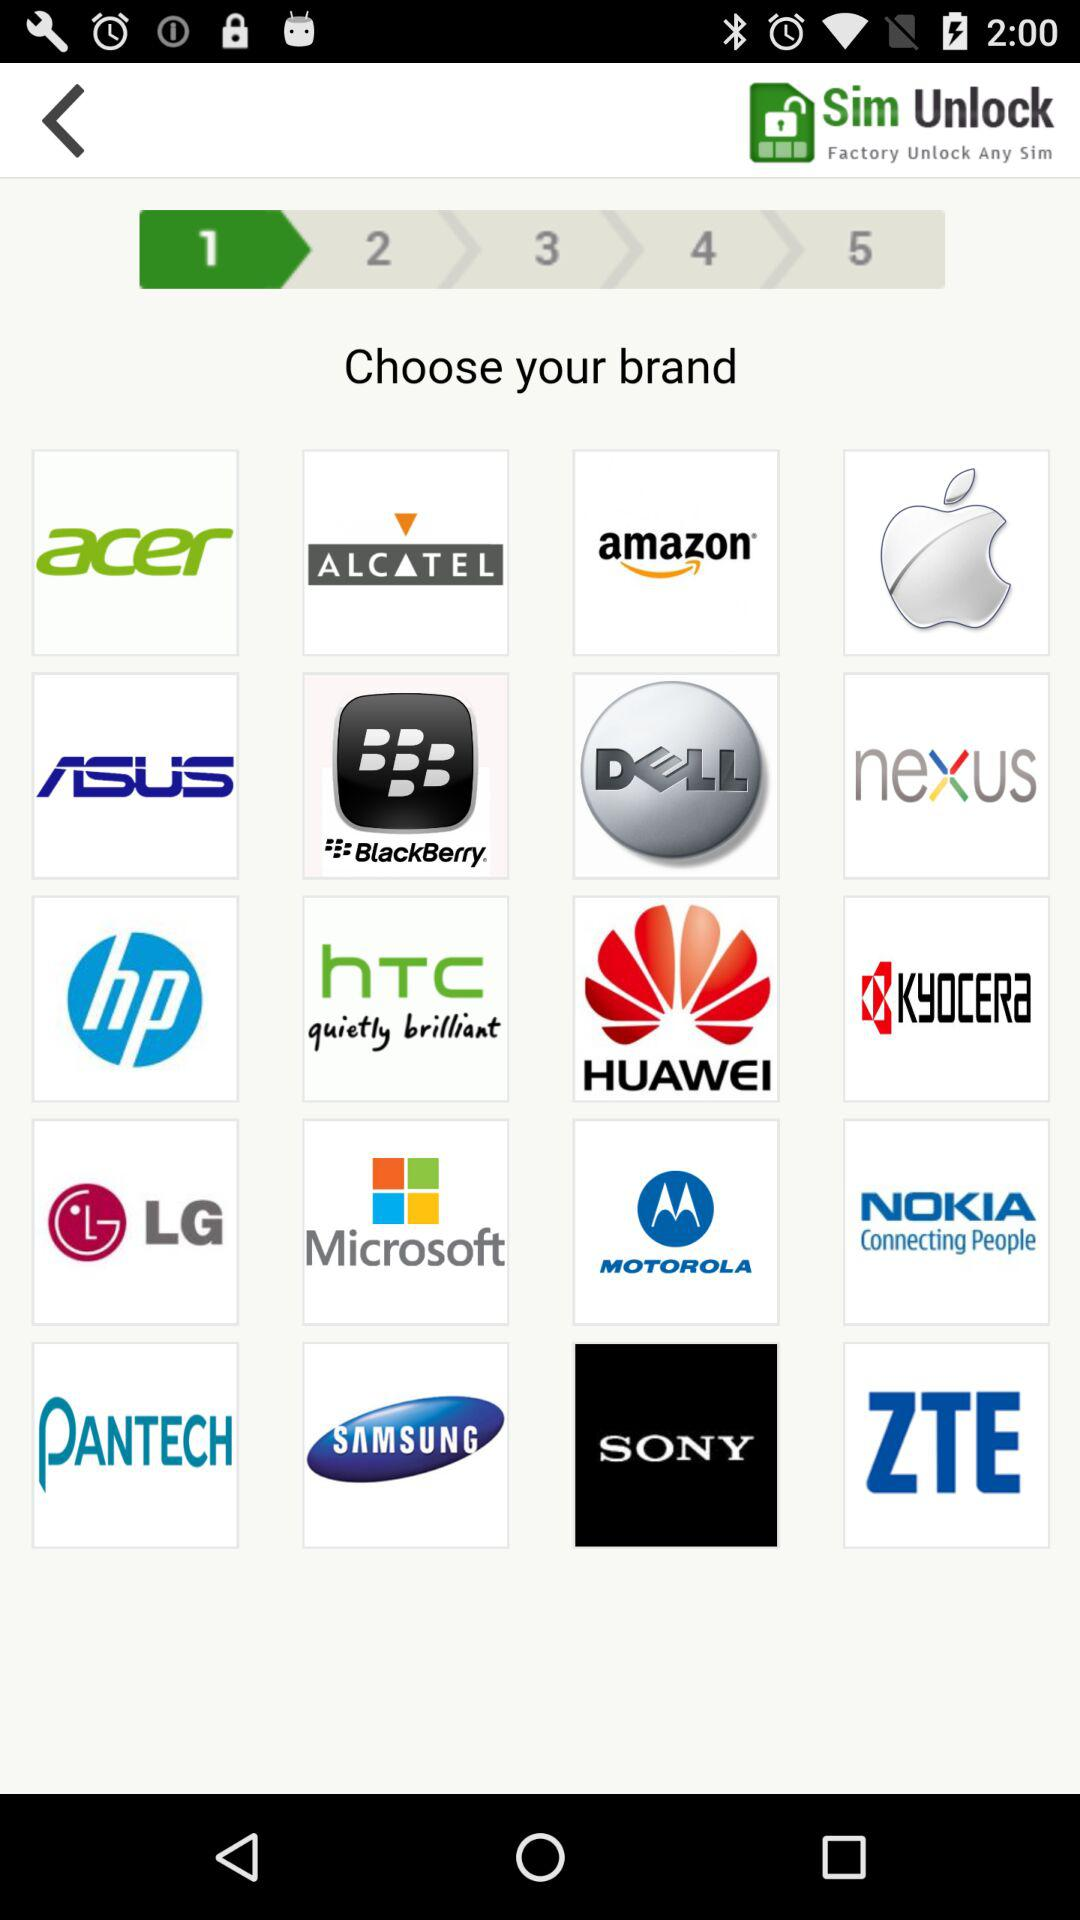Which step are we currently on? You are currently on the first step. 